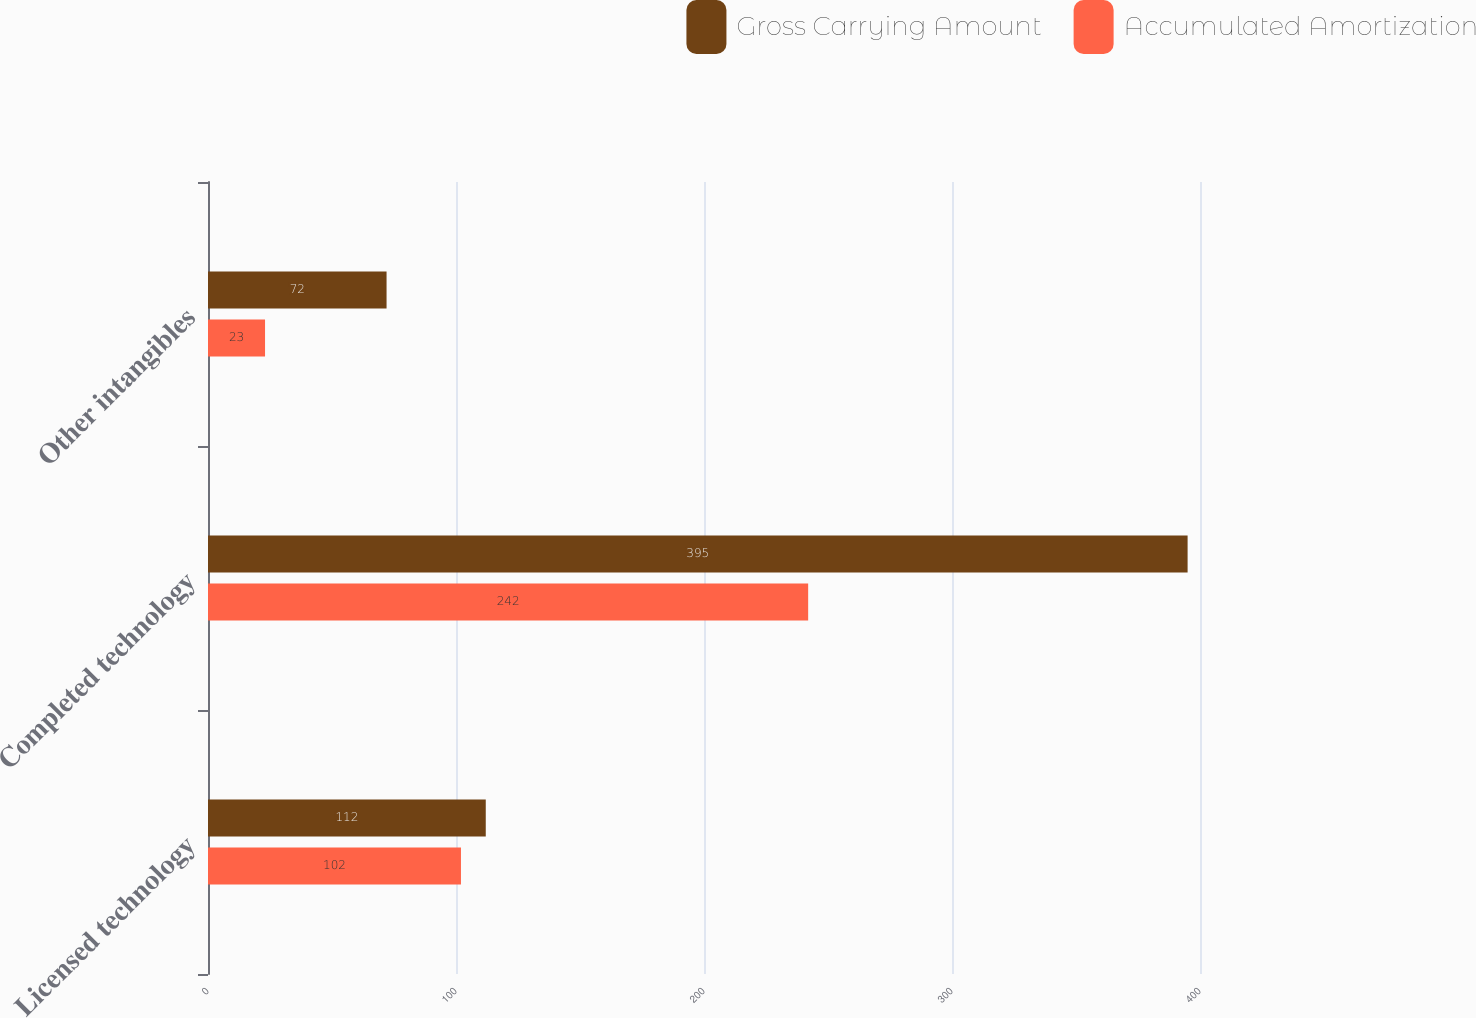Convert chart. <chart><loc_0><loc_0><loc_500><loc_500><stacked_bar_chart><ecel><fcel>Licensed technology<fcel>Completed technology<fcel>Other intangibles<nl><fcel>Gross Carrying Amount<fcel>112<fcel>395<fcel>72<nl><fcel>Accumulated Amortization<fcel>102<fcel>242<fcel>23<nl></chart> 